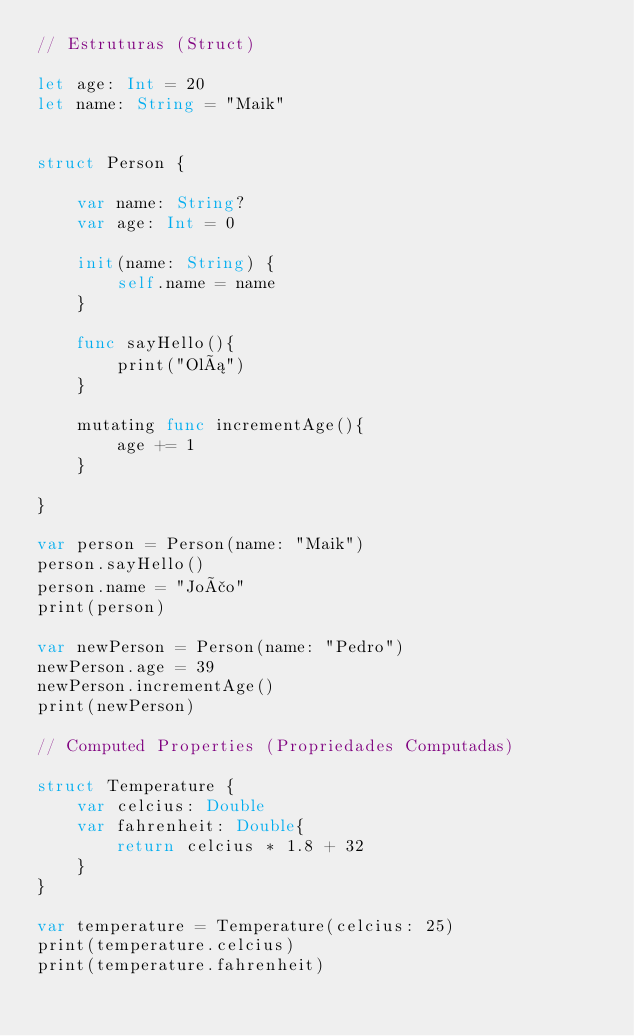<code> <loc_0><loc_0><loc_500><loc_500><_Swift_>// Estruturas (Struct)

let age: Int = 20
let name: String = "Maik"


struct Person {
    
    var name: String?
    var age: Int = 0
    
    init(name: String) {
        self.name = name
    }
    
    func sayHello(){
        print("Olá")
    }
    
    mutating func incrementAge(){
        age += 1
    }
    
}

var person = Person(name: "Maik")
person.sayHello()
person.name = "João"
print(person)

var newPerson = Person(name: "Pedro")
newPerson.age = 39
newPerson.incrementAge()
print(newPerson)

// Computed Properties (Propriedades Computadas)

struct Temperature {
    var celcius: Double
    var fahrenheit: Double{
        return celcius * 1.8 + 32
    }
}

var temperature = Temperature(celcius: 25)
print(temperature.celcius)
print(temperature.fahrenheit)









</code> 